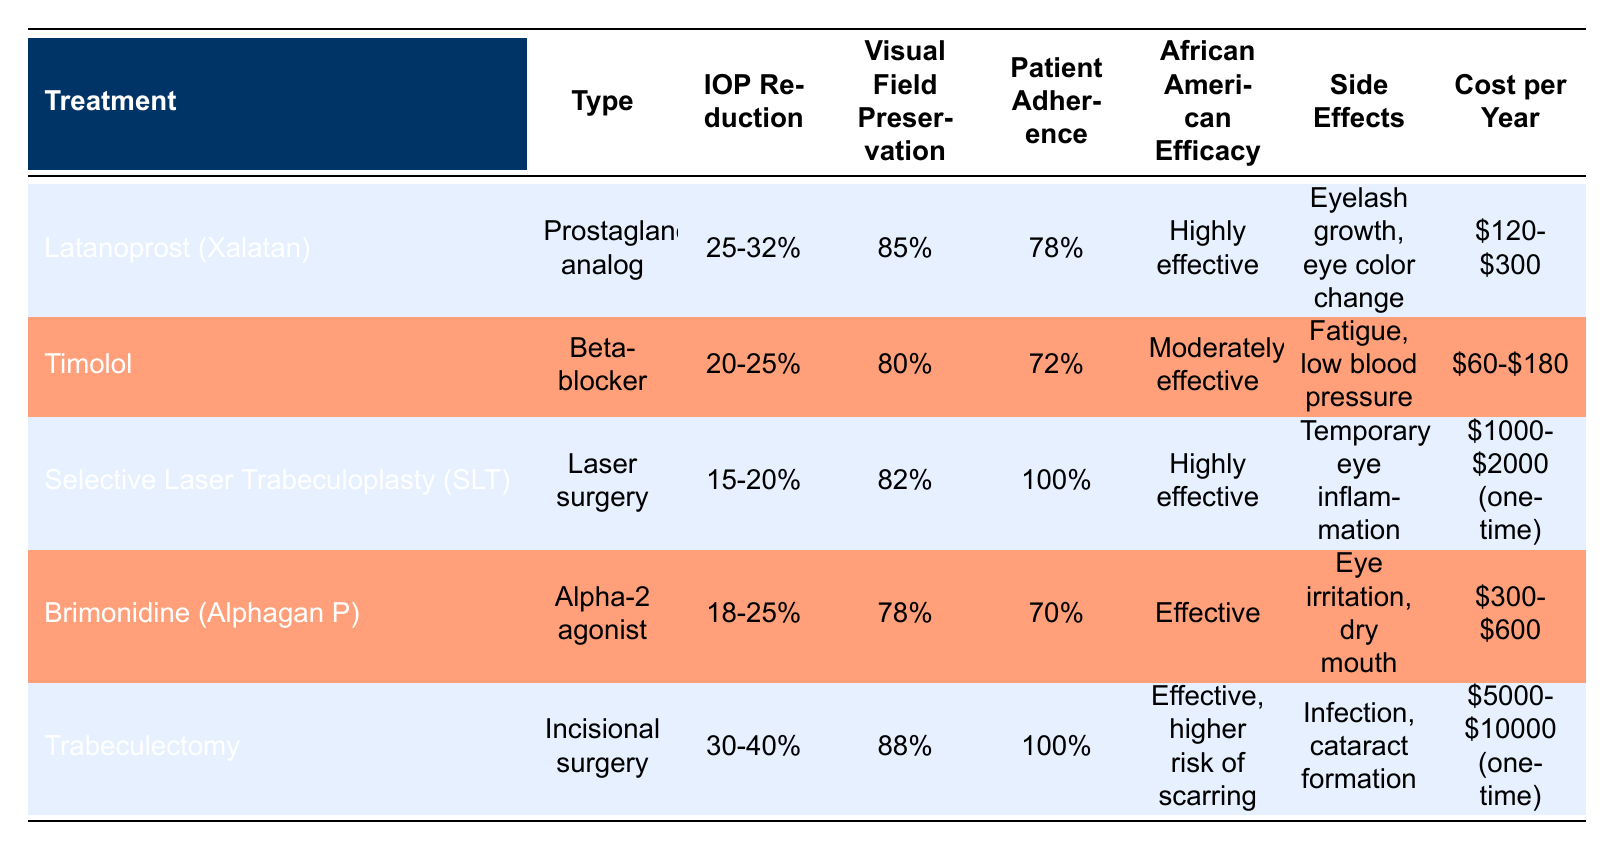What is the IOP reduction percentage for Trabeculectomy? The table shows that Trabeculectomy has an IOP reduction percentage of "30-40%."
Answer: 30-40% Which treatment has the highest patient adherence? Selective Laser Trabeculoplasty (SLT) has a patient adherence of "100%," which is higher than all other treatments listed.
Answer: 100% Is Latanoprost (Xalatan) more effective for African Americans compared to Timolol? The table indicates Latanoprost is "Highly effective" for African Americans, while Timolol is "Moderately effective." Yes, Latanoprost is more effective.
Answer: Yes What is the average cost per year for all treatments listed? Adding the costs: (120 + 300 + 60 + 180 + 1000 + 2000 + 300 + 600 + 5000 + 10000) = 10060. This gives an average of 10060/5 = 2012.
Answer: 2012 Are the side effects of Trabeculectomy more severe than those of Brimonidine? Trabeculectomy includes "Infection, cataract formation," and Brimonidine has "Eye irritation, dry mouth." Since infection and cataract formation can be more severe than eye irritation, the answer is yes.
Answer: Yes Which treatments preserve visual fields better, Trabeculectomy or SLT? Trabeculectomy has "88%" visual field preservation, while SLT has "82%." Since 88% is greater than 82%, Trabeculectomy preserves visual fields better.
Answer: Trabeculectomy What is the cost range for Latanoprost (Xalatan)? The table states that the cost per year for Latanoprost (Xalatan) is "$120-$300."
Answer: $120-$300 Does Selective Laser Trabeculoplasty have any side effects listed? The side effects for SLT in the table are "Temporary eye inflammation." Therefore, it does have listed side effects.
Answer: Yes Which treatment has the lowest percentage of visual field preservation? The treatment with the lowest visual field preservation is Brimonidine, with "78%," which is lower than the other treatments listed.
Answer: Brimonidine 